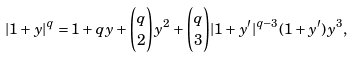<formula> <loc_0><loc_0><loc_500><loc_500>| 1 + y | ^ { q } = 1 + q y + \binom { q } { 2 } y ^ { 2 } + \binom { q } { 3 } | 1 + y ^ { \prime } | ^ { q - 3 } ( 1 + y ^ { \prime } ) y ^ { 3 } ,</formula> 